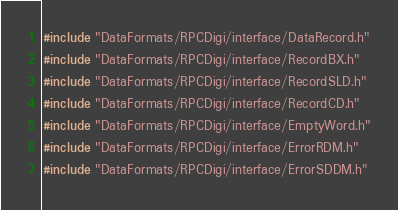<code> <loc_0><loc_0><loc_500><loc_500><_C++_>#include "DataFormats/RPCDigi/interface/DataRecord.h"
#include "DataFormats/RPCDigi/interface/RecordBX.h"
#include "DataFormats/RPCDigi/interface/RecordSLD.h"
#include "DataFormats/RPCDigi/interface/RecordCD.h"
#include "DataFormats/RPCDigi/interface/EmptyWord.h"
#include "DataFormats/RPCDigi/interface/ErrorRDM.h"
#include "DataFormats/RPCDigi/interface/ErrorSDDM.h"</code> 